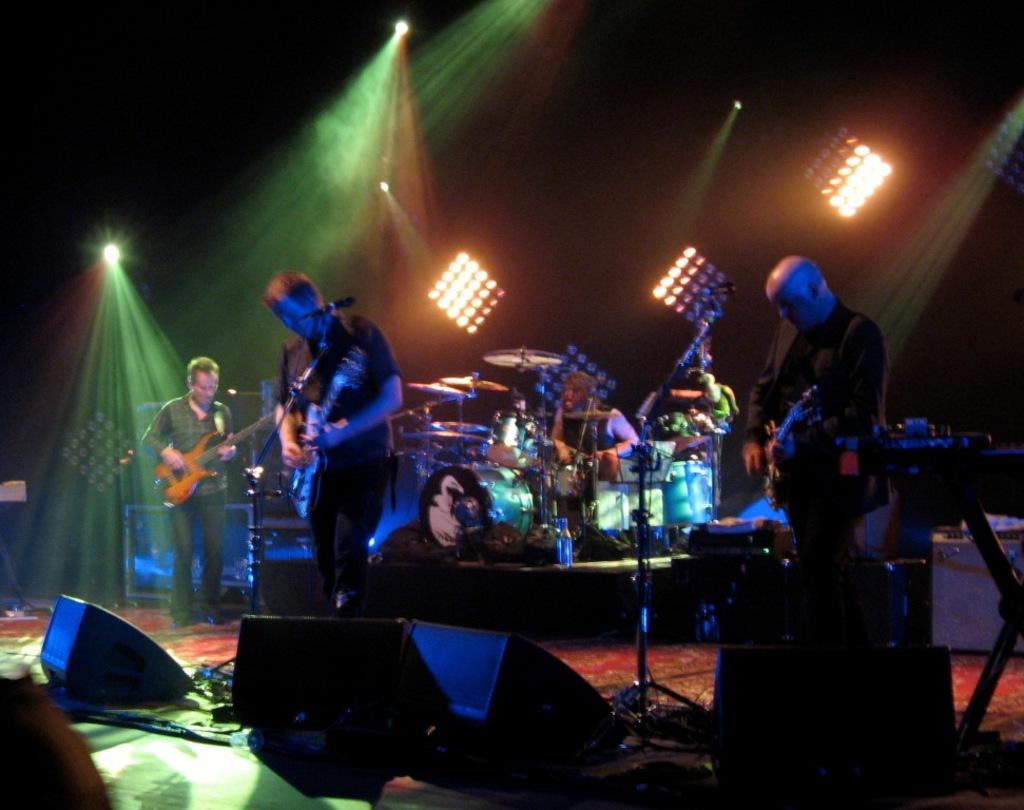How many people are in the image? There are three persons standing in the center of the image. What are the persons holding in the image? The persons are holding guitars. Can you describe any other musical instruments visible in the image? There are other musical instruments visible in the background. What is located in front of the persons? There is a speaker in front of the persons. What type of vegetable is being used as a drumstick in the image? There is no vegetable being used as a drumstick in the image; the persons are holding guitars and there are other musical instruments visible in the background. 